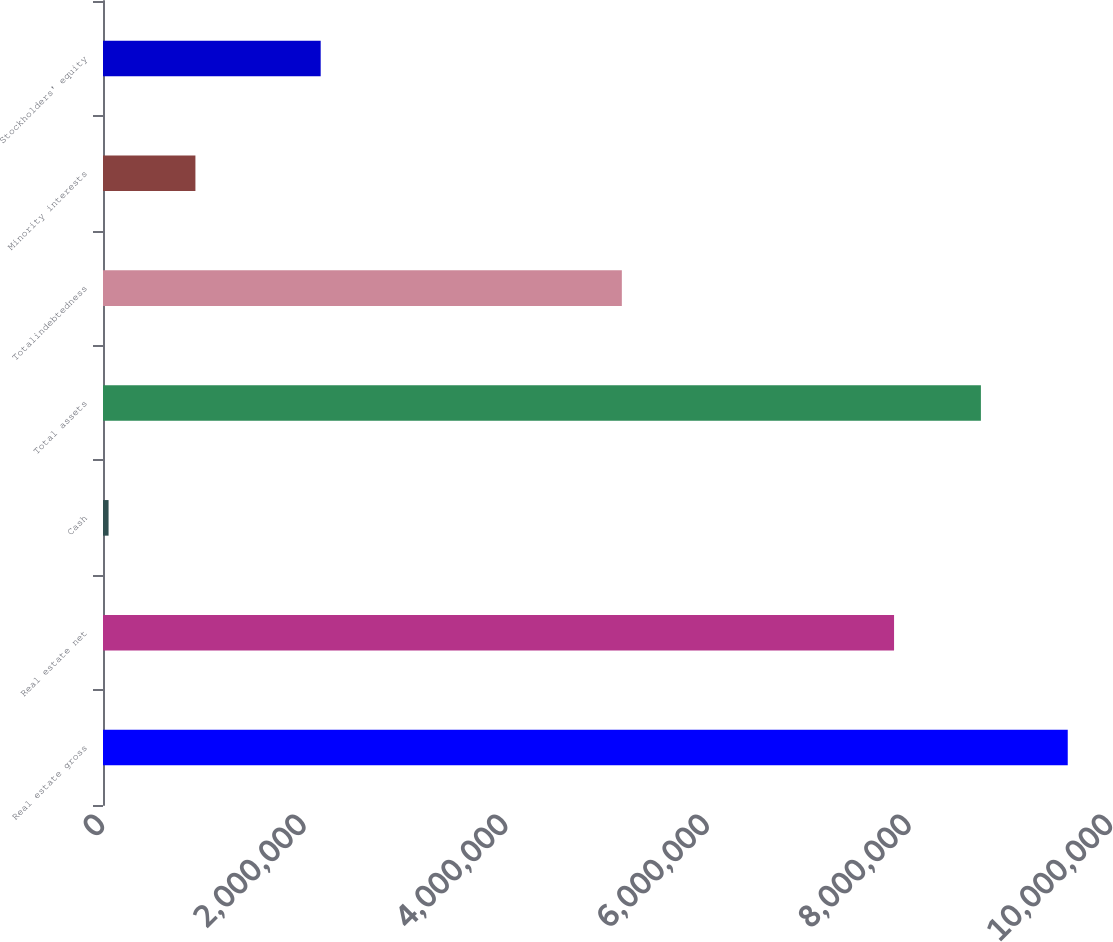Convert chart. <chart><loc_0><loc_0><loc_500><loc_500><bar_chart><fcel>Real estate gross<fcel>Real estate net<fcel>Cash<fcel>Total assets<fcel>Totalindebtedness<fcel>Minority interests<fcel>Stockholders' equity<nl><fcel>9.57087e+06<fcel>7.84778e+06<fcel>55275<fcel>8.70932e+06<fcel>5.14722e+06<fcel>916819<fcel>2.15959e+06<nl></chart> 